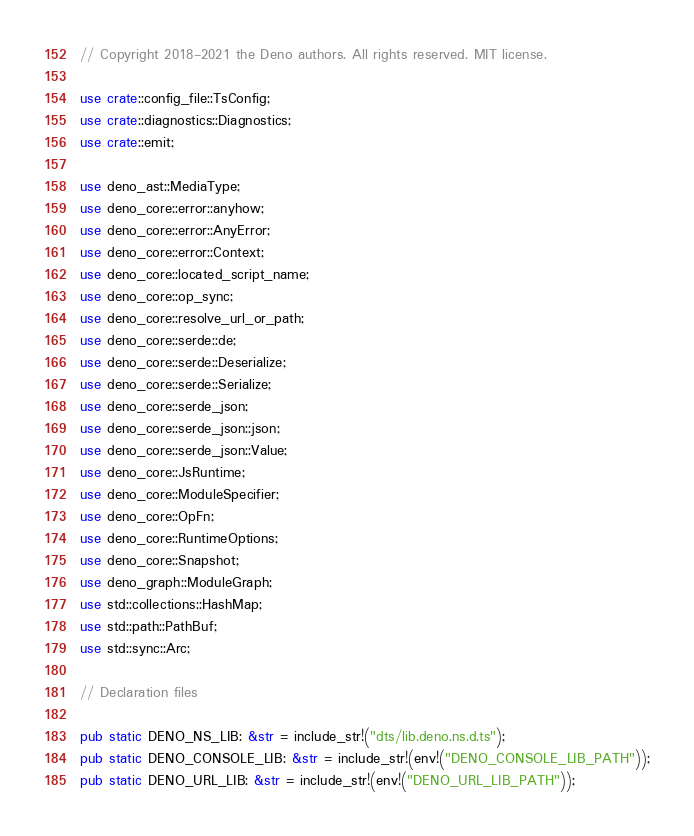Convert code to text. <code><loc_0><loc_0><loc_500><loc_500><_Rust_>// Copyright 2018-2021 the Deno authors. All rights reserved. MIT license.

use crate::config_file::TsConfig;
use crate::diagnostics::Diagnostics;
use crate::emit;

use deno_ast::MediaType;
use deno_core::error::anyhow;
use deno_core::error::AnyError;
use deno_core::error::Context;
use deno_core::located_script_name;
use deno_core::op_sync;
use deno_core::resolve_url_or_path;
use deno_core::serde::de;
use deno_core::serde::Deserialize;
use deno_core::serde::Serialize;
use deno_core::serde_json;
use deno_core::serde_json::json;
use deno_core::serde_json::Value;
use deno_core::JsRuntime;
use deno_core::ModuleSpecifier;
use deno_core::OpFn;
use deno_core::RuntimeOptions;
use deno_core::Snapshot;
use deno_graph::ModuleGraph;
use std::collections::HashMap;
use std::path::PathBuf;
use std::sync::Arc;

// Declaration files

pub static DENO_NS_LIB: &str = include_str!("dts/lib.deno.ns.d.ts");
pub static DENO_CONSOLE_LIB: &str = include_str!(env!("DENO_CONSOLE_LIB_PATH"));
pub static DENO_URL_LIB: &str = include_str!(env!("DENO_URL_LIB_PATH"));</code> 